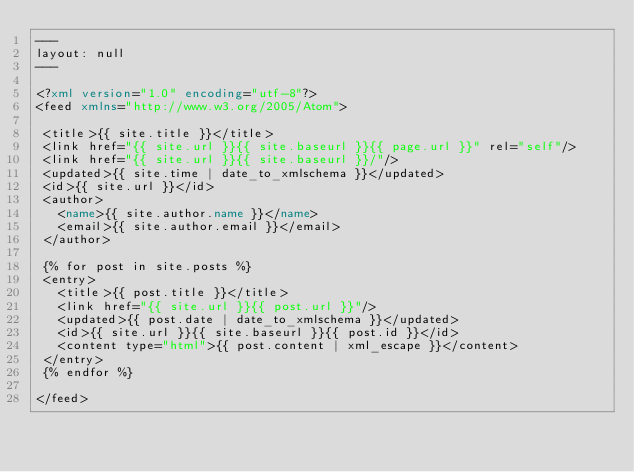<code> <loc_0><loc_0><loc_500><loc_500><_XML_>---
layout: null
---

<?xml version="1.0" encoding="utf-8"?>
<feed xmlns="http://www.w3.org/2005/Atom">

 <title>{{ site.title }}</title>
 <link href="{{ site.url }}{{ site.baseurl }}{{ page.url }}" rel="self"/>
 <link href="{{ site.url }}{{ site.baseurl }}/"/>
 <updated>{{ site.time | date_to_xmlschema }}</updated>
 <id>{{ site.url }}</id>
 <author>
   <name>{{ site.author.name }}</name>
   <email>{{ site.author.email }}</email>
 </author>

 {% for post in site.posts %}
 <entry>
   <title>{{ post.title }}</title>
   <link href="{{ site.url }}{{ post.url }}"/>
   <updated>{{ post.date | date_to_xmlschema }}</updated>
   <id>{{ site.url }}{{ site.baseurl }}{{ post.id }}</id>
   <content type="html">{{ post.content | xml_escape }}</content>
 </entry>
 {% endfor %}

</feed>
</code> 